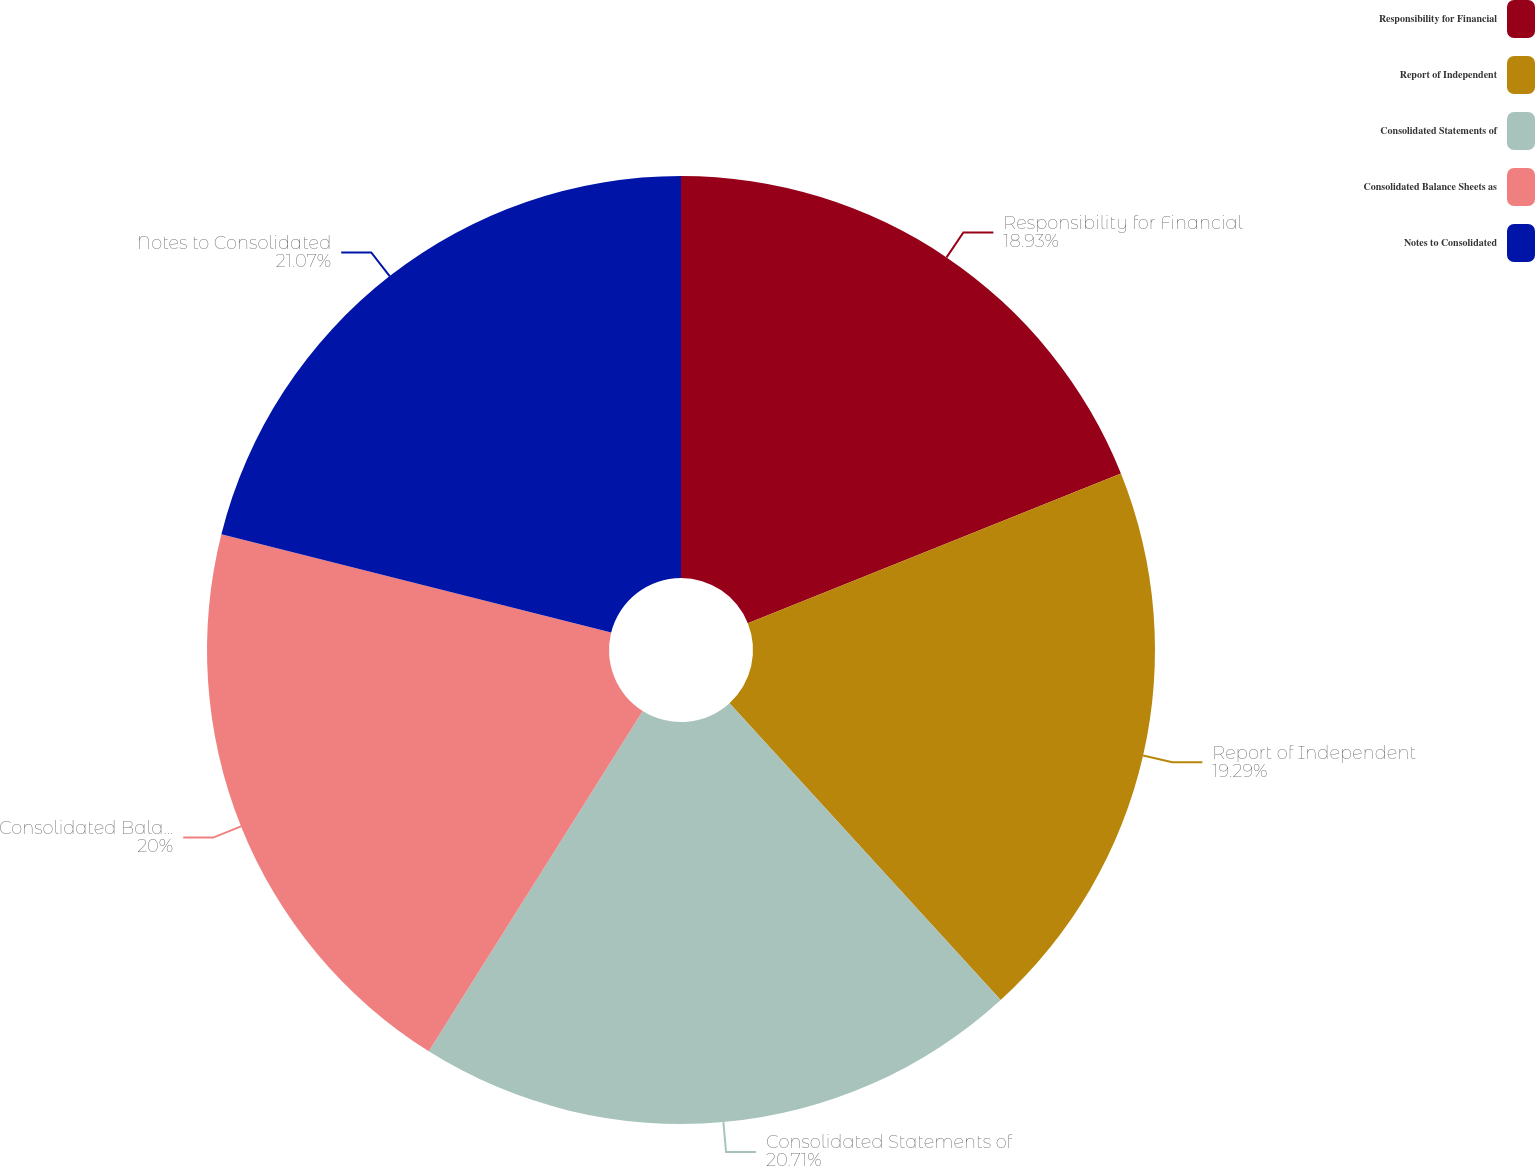Convert chart. <chart><loc_0><loc_0><loc_500><loc_500><pie_chart><fcel>Responsibility for Financial<fcel>Report of Independent<fcel>Consolidated Statements of<fcel>Consolidated Balance Sheets as<fcel>Notes to Consolidated<nl><fcel>18.93%<fcel>19.29%<fcel>20.71%<fcel>20.0%<fcel>21.07%<nl></chart> 